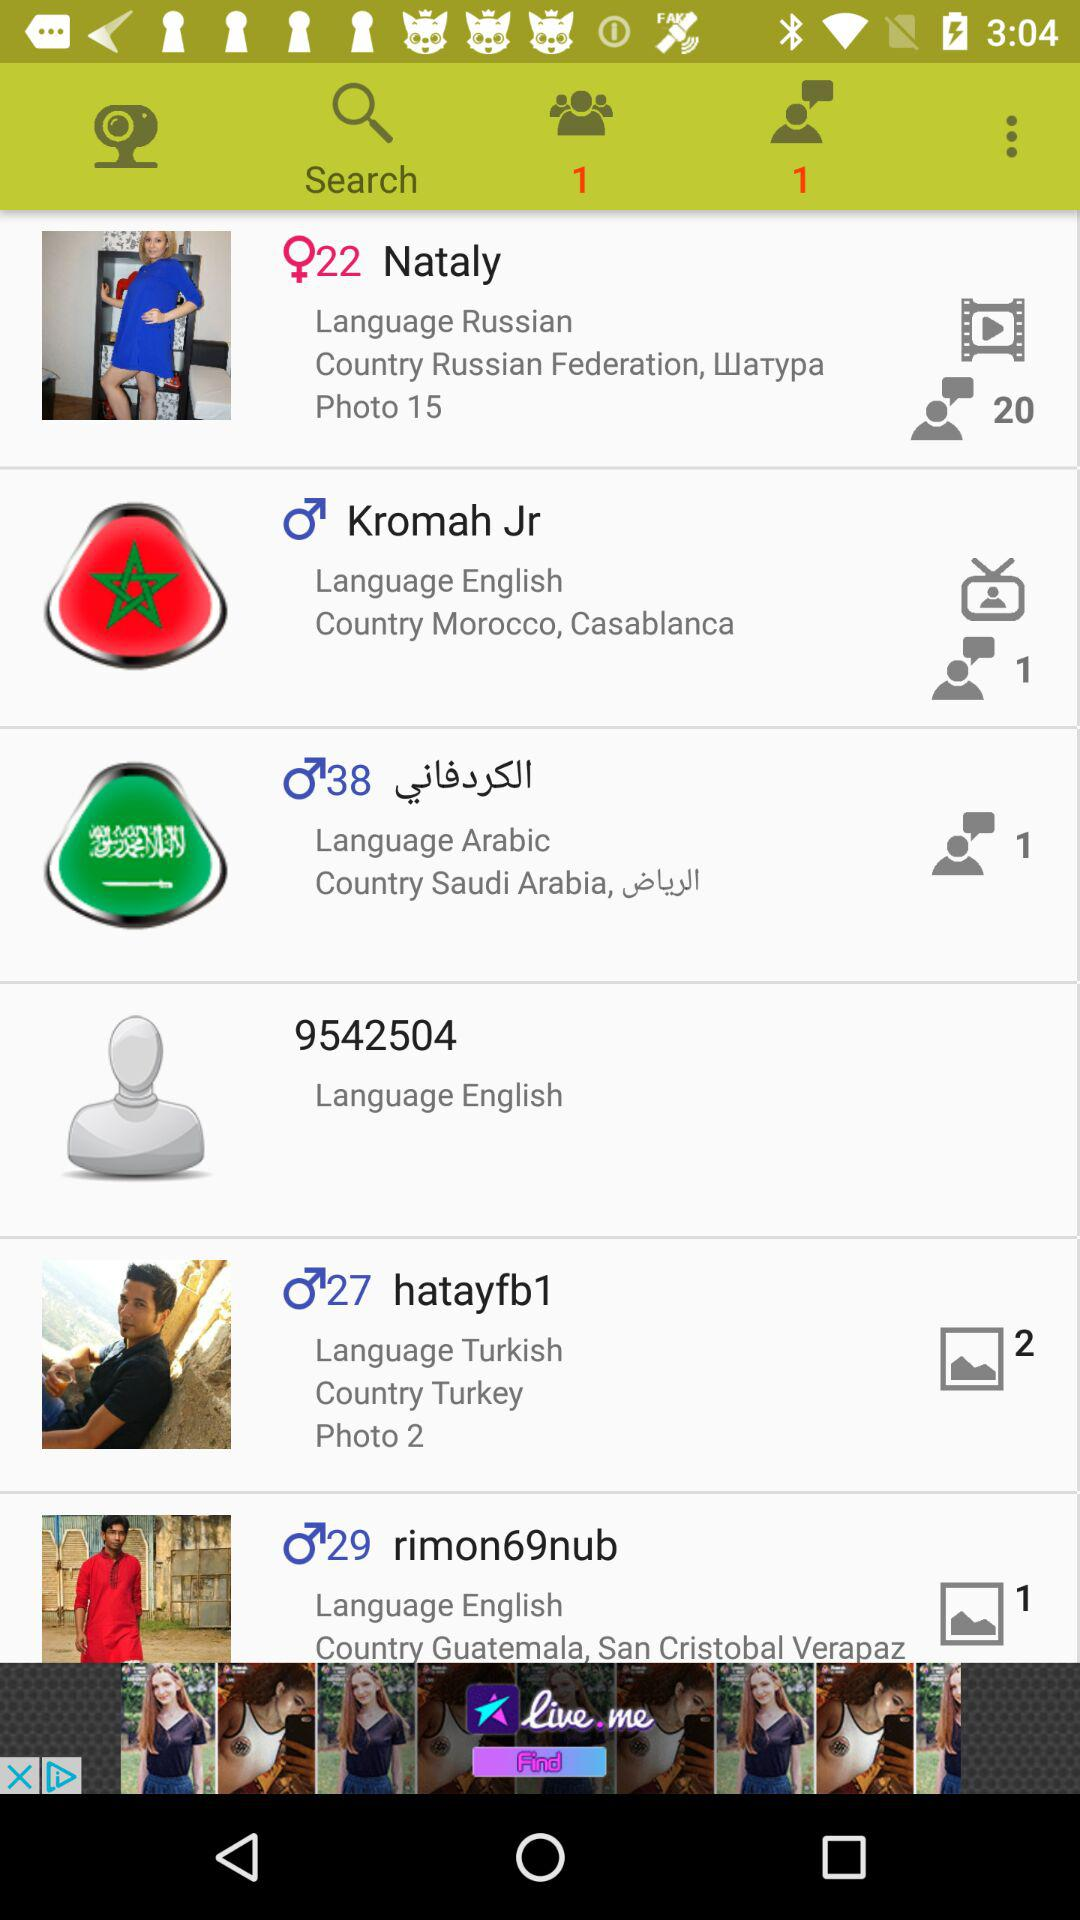Who speaks the English language? The English language is spoken by Kromah Jr., "9542504" and "rimon69nub". 